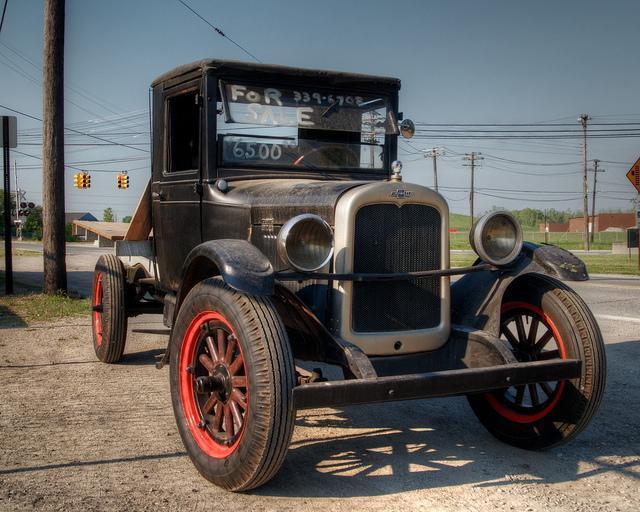How many people are there?
Give a very brief answer. 0. 